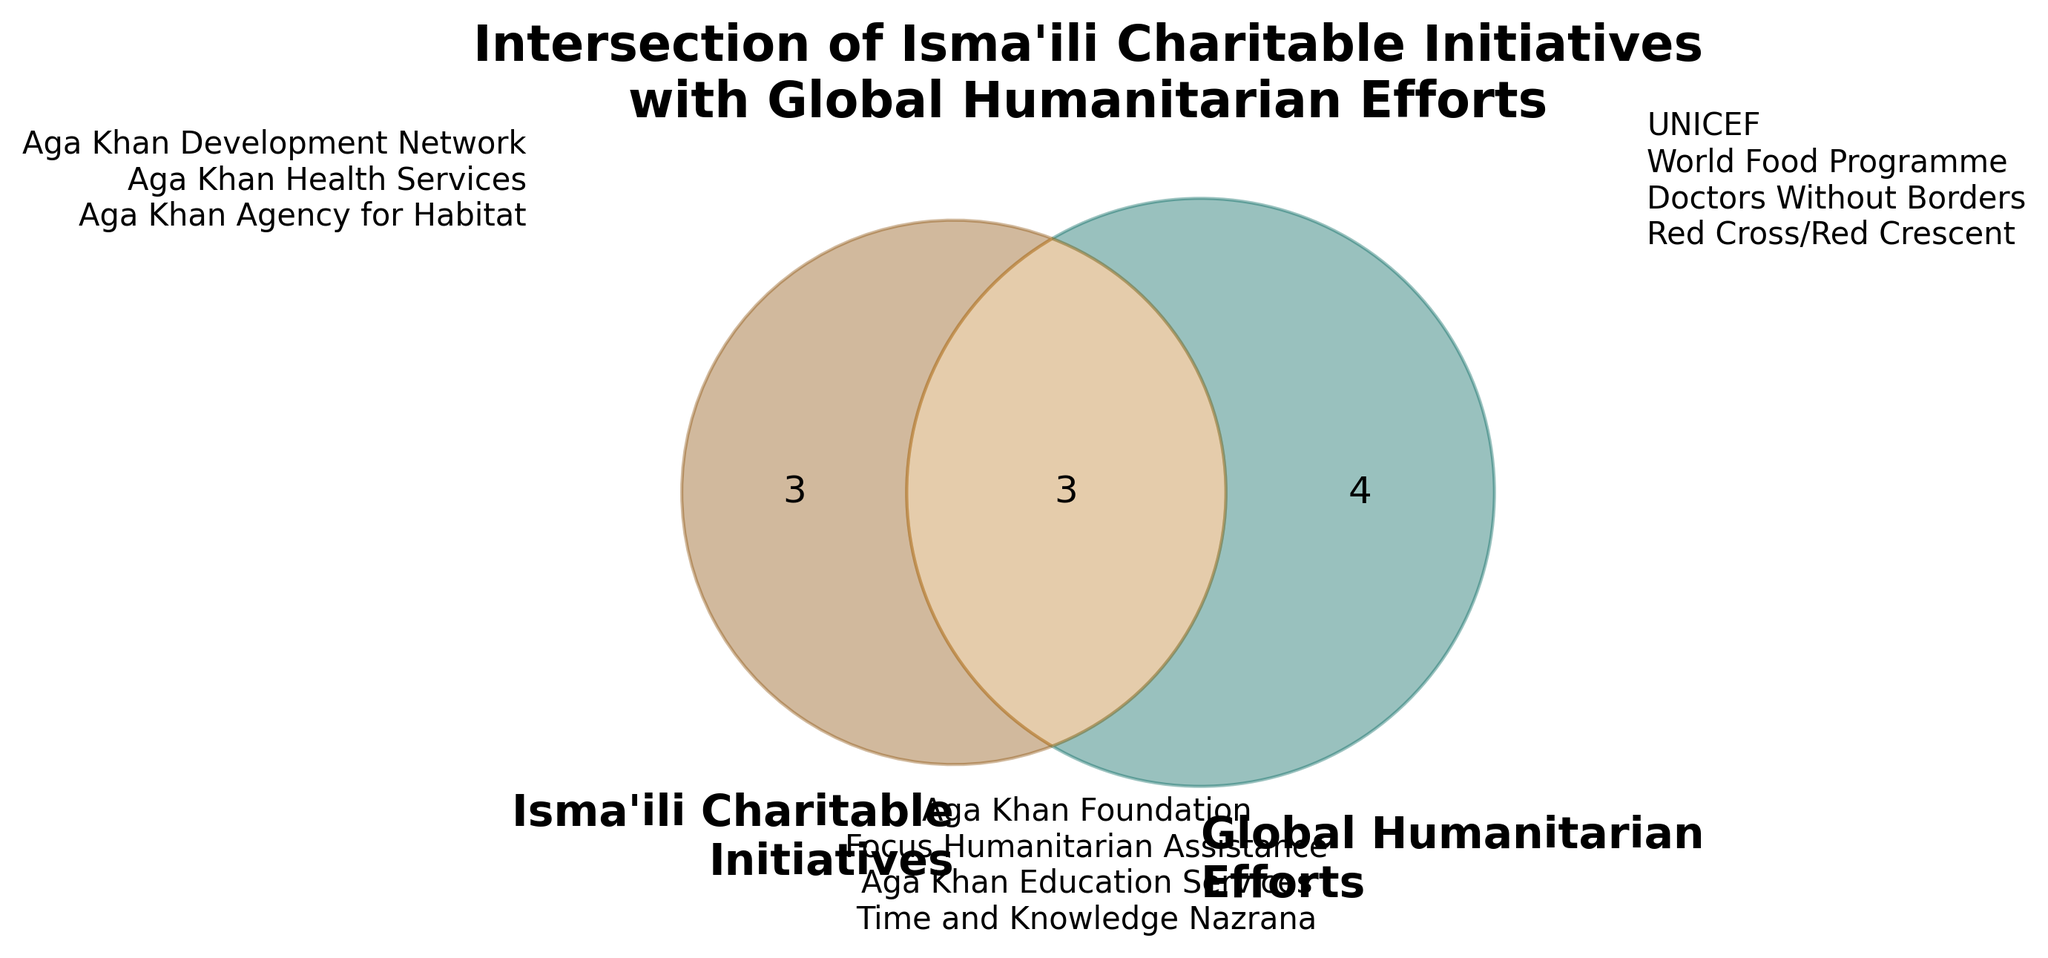What are the two sets in the Venn Diagram? The Venn Diagram shows two sets: Isma'ili Charitable Initiatives and Global Humanitarian Efforts. Each set is labeled separately on the diagram.
Answer: Isma'ili Charitable Initiatives, Global Humanitarian Efforts How many initiatives have an intersection with global humanitarian efforts? The intersection in the Venn Diagram is visually represented by where the two circles overlap. The sets indicate three elements in this overlapping section.
Answer: 3 Which organizations fall solely under Isma'ili charitable initiatives? These organizations are listed outside the overlapping part of the Venn Diagram. According to the annotations, they include Aga Khan Development Network, Aga Khan Health Services, and Aga Khan Agency for Habitat.
Answer: Aga Khan Development Network, Aga Khan Health Services, Aga Khan Agency for Habitat Which organizations fall solely under global humanitarian efforts? Looking at the section annotated for Global Humanitarian Efforts but not intersecting with Isma'ili Charitable Initiatives, the organizations here are UNICEF, World Food Programme, Doctors Without Borders, and Red Cross/Red Crescent.
Answer: UNICEF, World Food Programme, Doctors Without Borders, Red Cross/Red Crescent What is the title of the Venn Diagram? The title of the Venn Diagram is found at the top of the figure and reads "Intersection of Isma'ili Charitable Initiatives with Global Humanitarian Efforts."
Answer: Intersection of Isma’ili Charitable Initiatives with Global Humanitarian Efforts How many organizations are in total within the Isma'ili Charitable Initiatives set? To determine this, we can count the names in both the Isma'ili Charitable Initiatives section and the intersection section. There are 3 unique organizations plus 3 that overlap, totaling 6.
Answer: 6 Which specific Isma'ili charitable initiatives are in the intersection with global humanitarian efforts? The organizations listed within the intersection area include Aga Khan Foundation, Focus Humanitarian Assistance, and Time and Knowledge Nazrana.
Answer: Aga Khan Foundation, Focus Humanitarian Assistance, Time and Knowledge Nazrana Are there more unique organizations in Isma'ili Charitable Initiatives or Global Humanitarian Efforts? Count the non-intersecting entries in both sets: Isma'ili Charitable Initiatives has 3 unique entries, and Global Humanitarian Efforts has 4 unique. Since 4 > 3, Global Humanitarian Efforts has more unique organizations.
Answer: Global Humanitarian Efforts What color represents the intersection area in the Venn Diagram? The intersection area is shaded with a distinctive color that seems to blend characteristics of the two individual colors representing each set. It appears as a third, unique color.
Answer: Brown 